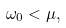Convert formula to latex. <formula><loc_0><loc_0><loc_500><loc_500>\omega _ { 0 } < \mu ,</formula> 